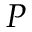<formula> <loc_0><loc_0><loc_500><loc_500>P</formula> 